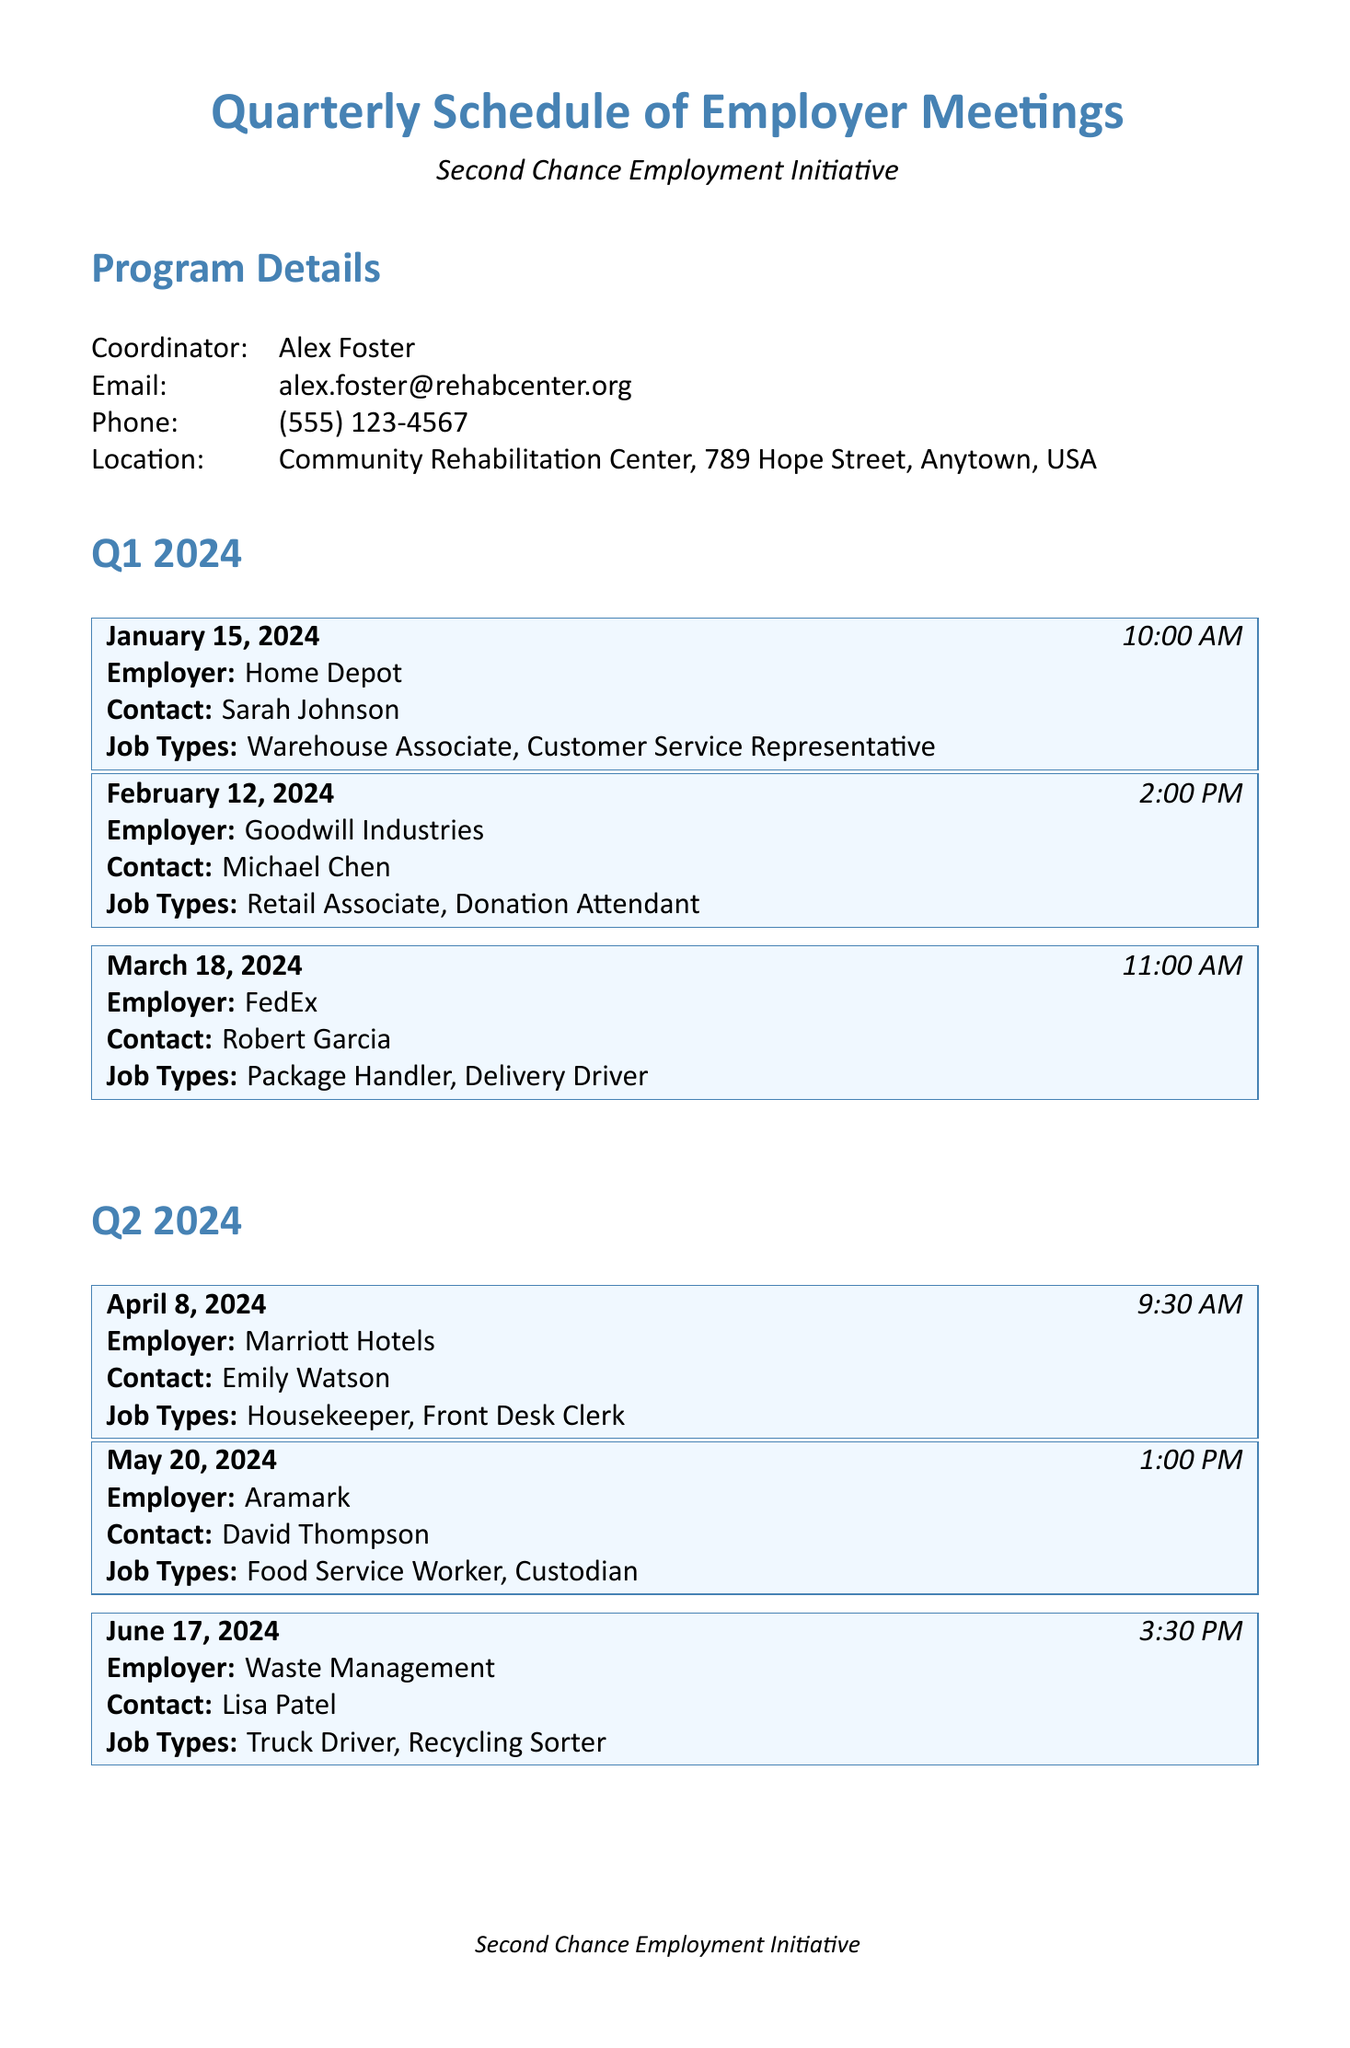What is the name of the program? The program is identified as the "Second Chance Employment Initiative" in the document.
Answer: Second Chance Employment Initiative Who is the coordinator of the program? The document specifies Alex Foster as the coordinator for the program.
Answer: Alex Foster What is the date of the meeting with Amazon? To find the date of the meeting, we look under Q4 2024, where it clearly states the meeting with Amazon is on October 14, 2024.
Answer: October 14, 2024 Which employer has a meeting on March 18, 2024? The document lists FedEx as the employer for the meeting scheduled on March 18, 2024.
Answer: FedEx How many job types are listed for Goodwill Industries? The document indicates there are two job types listed for Goodwill Industries during the meeting.
Answer: 2 What time is the meeting with Waste Management? The meeting time for Waste Management is detailed as 3:30 PM in the document.
Answer: 3:30 PM What is one requirement for participants in the program? The document states various participant requirements, one of which is the "Completion of job readiness training."
Answer: Completion of job readiness training Which employer is associated with the contact Sarah Johnson? Sarah Johnson is listed as the contact for Home Depot according to the document.
Answer: Home Depot How many meetings are scheduled for Q2 2024? The document outlines three meetings scheduled for Q2 2024 under that quarter's section.
Answer: 3 